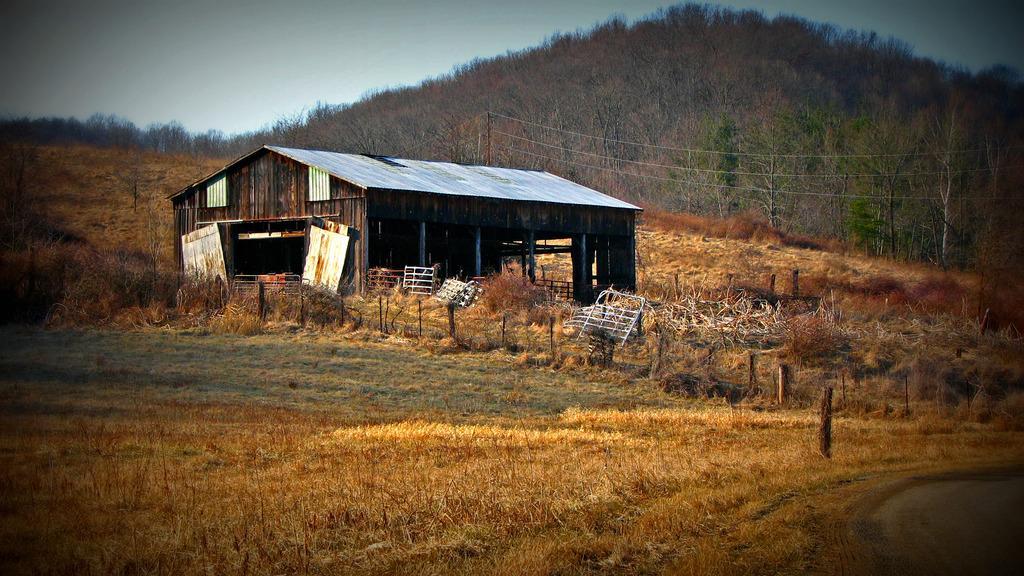Describe this image in one or two sentences. In this image in the center there is one house and some boards and fence, at the bottom there is grass and a walkway and in the background there are some trees and at the top of the image there is sky. 